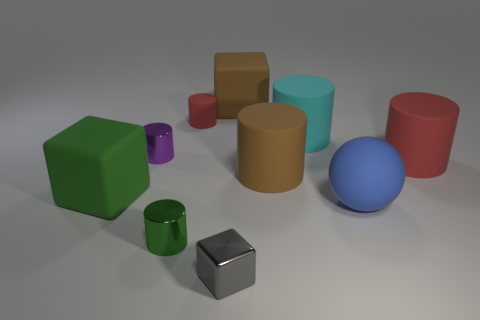How many large objects are cyan rubber things or cubes?
Offer a very short reply. 3. Is the color of the sphere the same as the shiny cube?
Offer a very short reply. No. Are there more small objects behind the large green thing than green cubes in front of the big red rubber thing?
Your answer should be compact. Yes. There is a big matte object behind the large cyan matte thing; is its color the same as the metal block?
Ensure brevity in your answer.  No. Are there any other things that are the same color as the tiny matte cylinder?
Your answer should be very brief. Yes. Is the number of tiny red things that are to the right of the big ball greater than the number of small gray things?
Offer a very short reply. No. Does the purple cylinder have the same size as the cyan rubber thing?
Ensure brevity in your answer.  No. What is the material of the cyan thing that is the same shape as the purple thing?
Offer a very short reply. Rubber. How many blue things are either metal objects or balls?
Your answer should be compact. 1. There is a big brown thing that is in front of the cyan rubber cylinder; what material is it?
Offer a terse response. Rubber. 